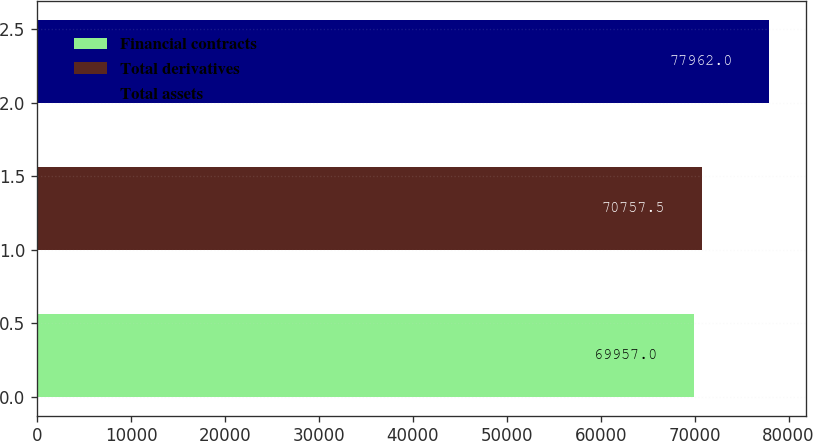<chart> <loc_0><loc_0><loc_500><loc_500><bar_chart><fcel>Financial contracts<fcel>Total derivatives<fcel>Total assets<nl><fcel>69957<fcel>70757.5<fcel>77962<nl></chart> 